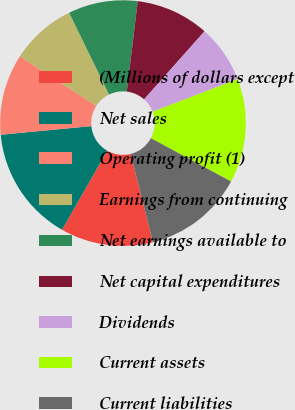<chart> <loc_0><loc_0><loc_500><loc_500><pie_chart><fcel>(Millions of dollars except<fcel>Net sales<fcel>Operating profit (1)<fcel>Earnings from continuing<fcel>Net earnings available to<fcel>Net capital expenditures<fcel>Dividends<fcel>Current assets<fcel>Current liabilities<nl><fcel>12.18%<fcel>15.23%<fcel>10.66%<fcel>8.63%<fcel>9.14%<fcel>9.64%<fcel>7.61%<fcel>13.71%<fcel>13.2%<nl></chart> 